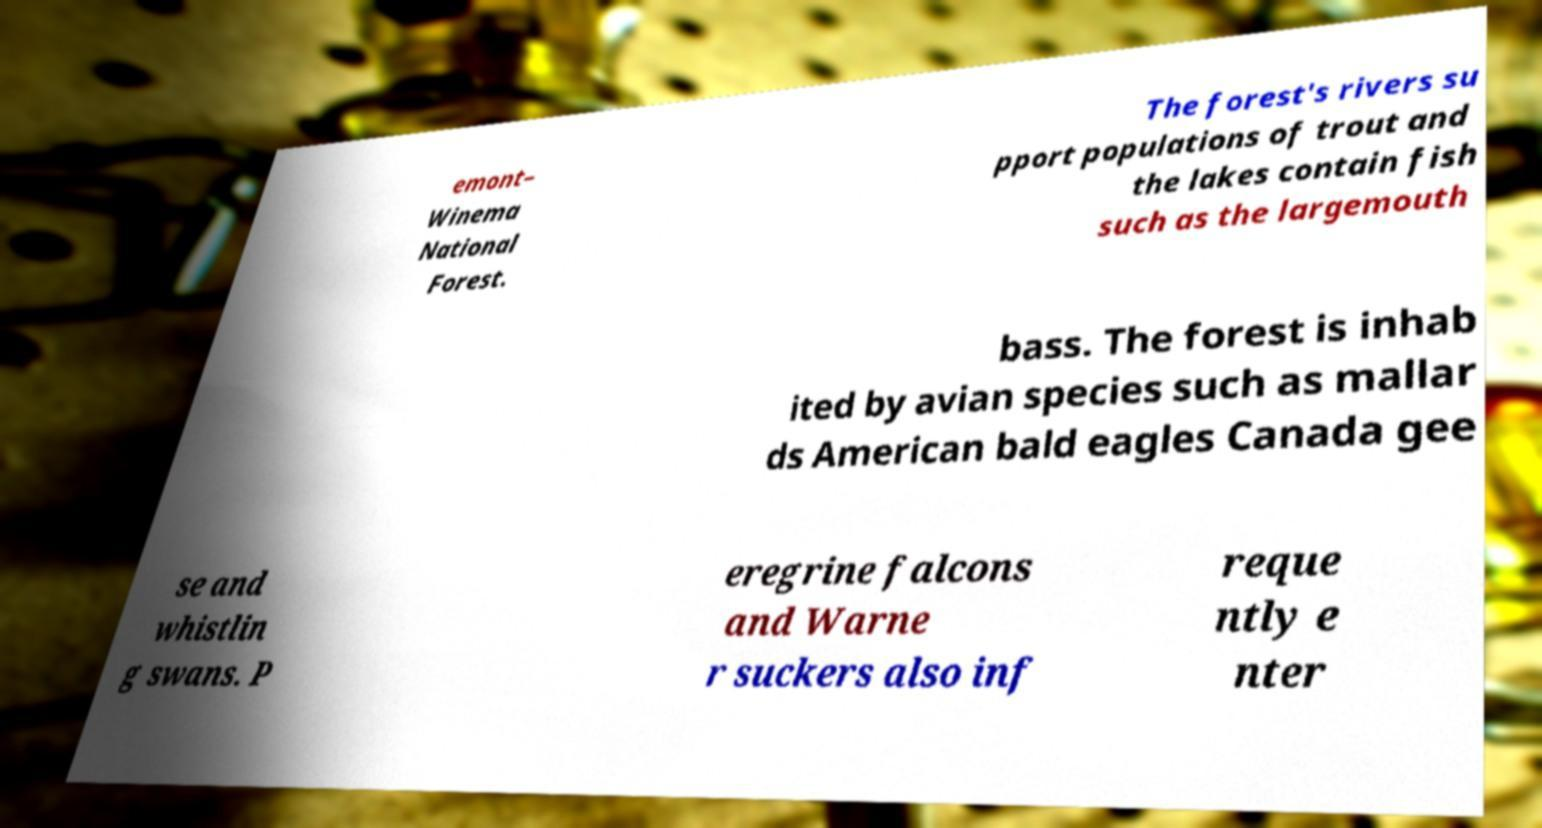Please identify and transcribe the text found in this image. emont– Winema National Forest. The forest's rivers su pport populations of trout and the lakes contain fish such as the largemouth bass. The forest is inhab ited by avian species such as mallar ds American bald eagles Canada gee se and whistlin g swans. P eregrine falcons and Warne r suckers also inf reque ntly e nter 